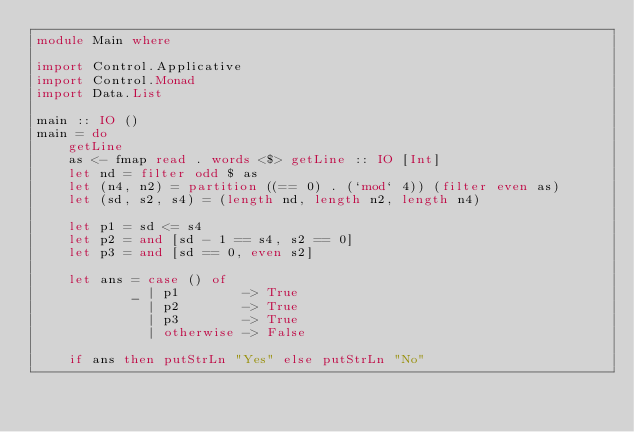<code> <loc_0><loc_0><loc_500><loc_500><_Haskell_>module Main where

import Control.Applicative
import Control.Monad
import Data.List

main :: IO ()
main = do
    getLine
    as <- fmap read . words <$> getLine :: IO [Int]
    let nd = filter odd $ as
    let (n4, n2) = partition ((== 0) . (`mod` 4)) (filter even as)
    let (sd, s2, s4) = (length nd, length n2, length n4)

    let p1 = sd <= s4
    let p2 = and [sd - 1 == s4, s2 == 0]
    let p3 = and [sd == 0, even s2]

    let ans = case () of
            _ | p1        -> True
              | p2        -> True
              | p3        -> True
              | otherwise -> False

    if ans then putStrLn "Yes" else putStrLn "No"</code> 